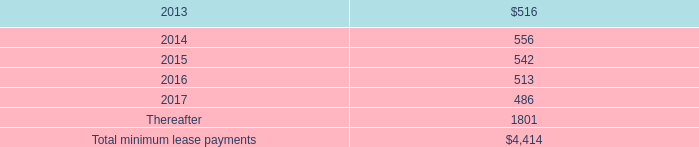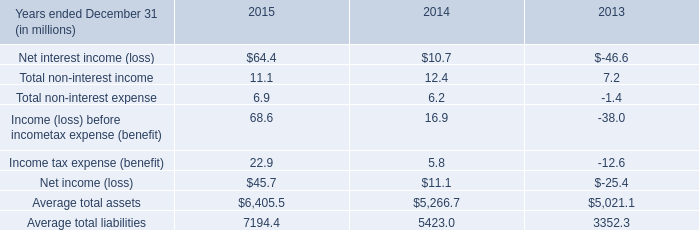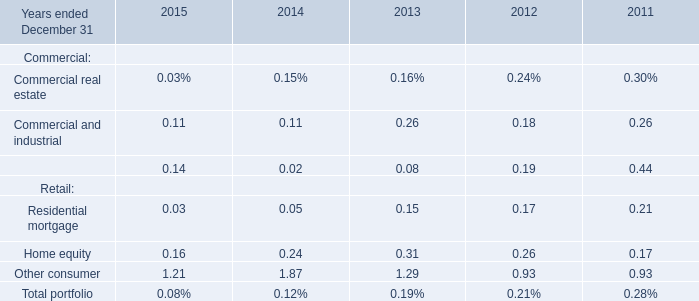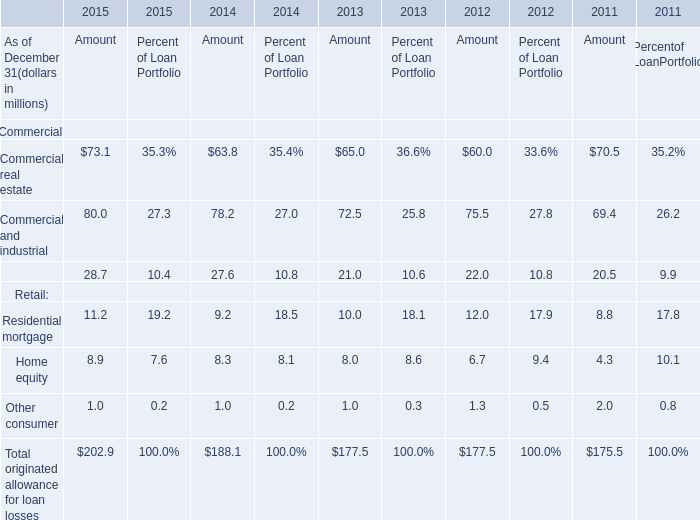what was the percentage change in rent expense under operating leases from 2010 to 2011? 
Computations: ((338 - 271) / 271)
Answer: 0.24723. 